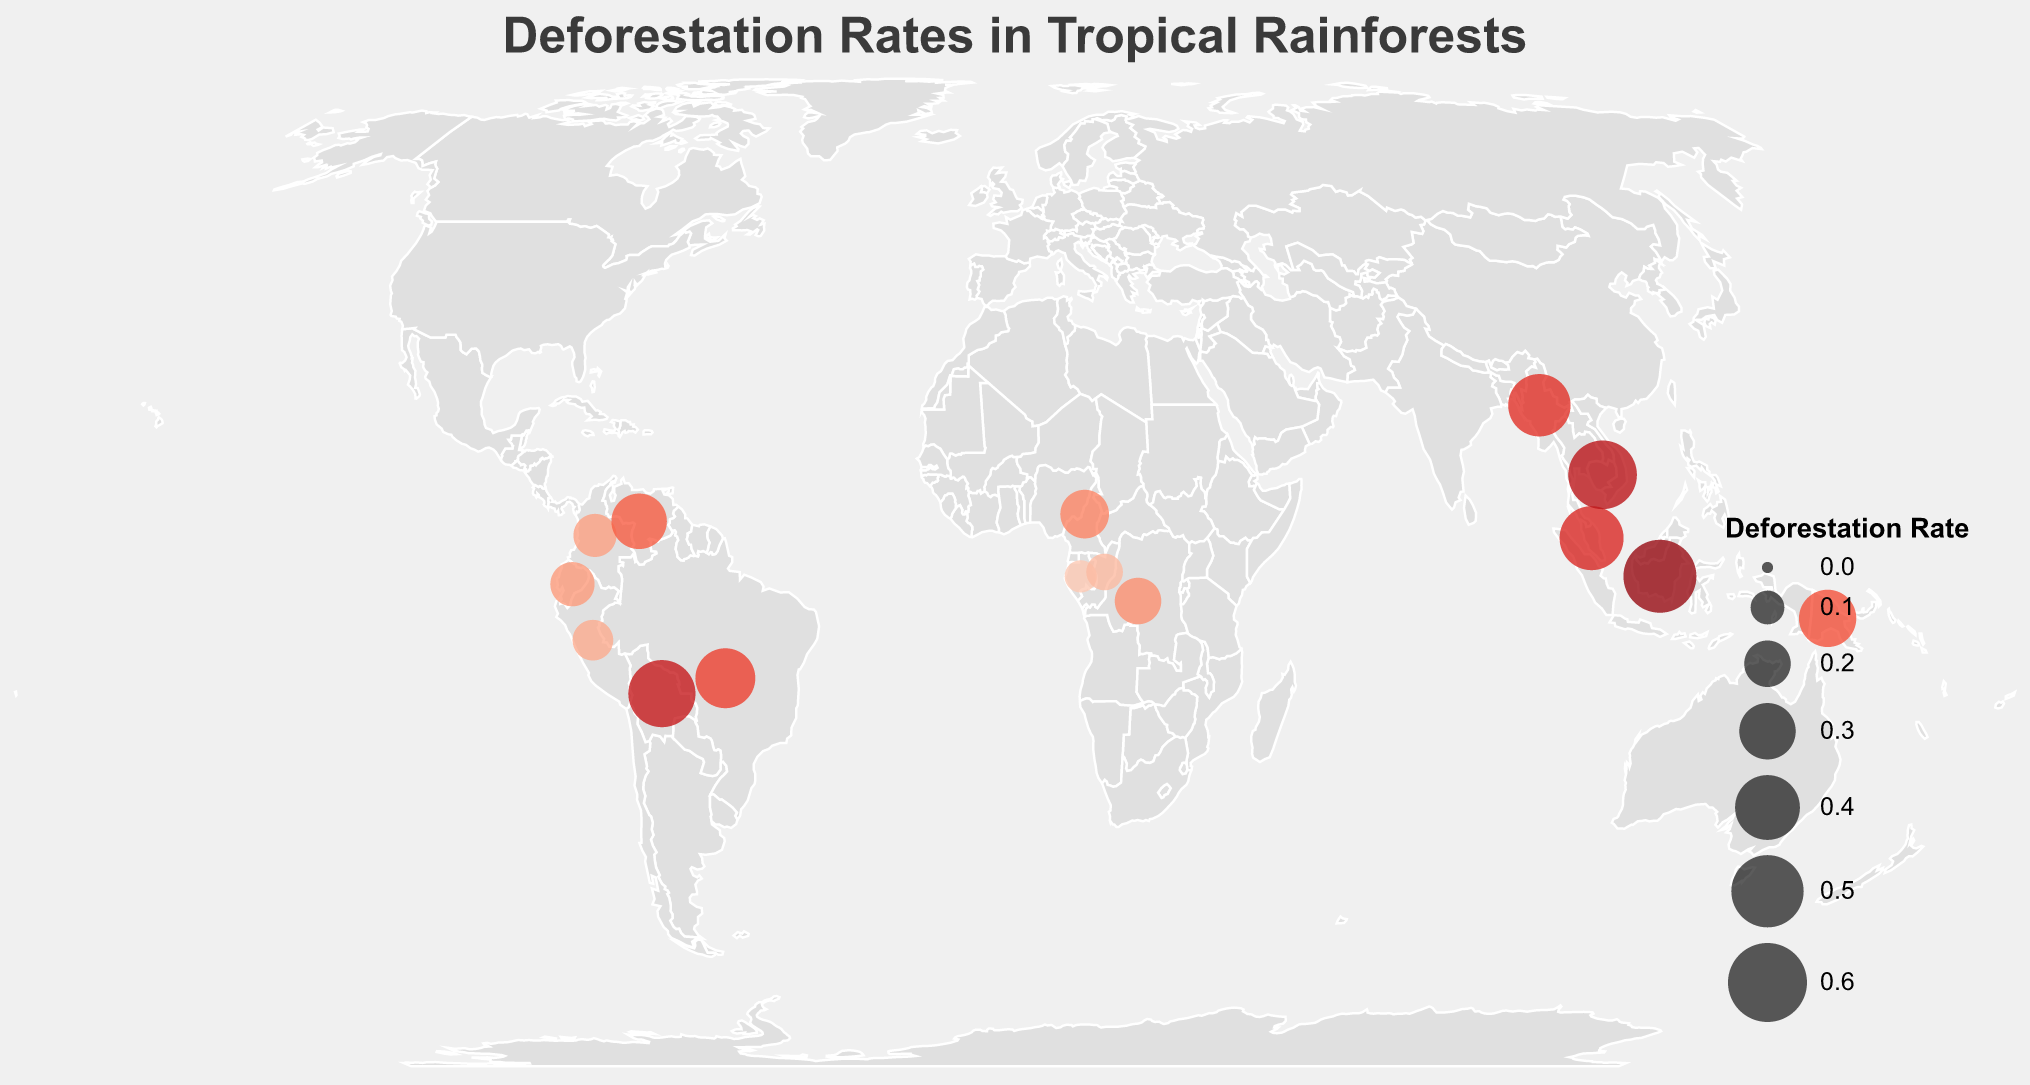What's the title of the figure? The title of the figure is displayed at the top and reads "Deforestation Rates in Tropical Rainforests".
Answer: Deforestation Rates in Tropical Rainforests How many countries are shown in the figure with deforestation rates? By counting the number of distinct data points or circles on the map, we can see there are 15 countries represented.
Answer: 15 Which country has the highest deforestation rate? By examining the figure and observing the sizes and colors of the circles representing deforestation rates, Indonesia has the largest circle, indicating the highest deforestation rate.
Answer: Indonesia What is the deforestation rate in Gabon? By hovering over or looking closely at the circle positioned over Gabon, the tooltip shows a deforestation rate of 0.09.
Answer: 0.09 Which two countries have similar deforestation rates of around 0.31? From the figure, the countries with deforestation rates close to 0.31 are Brazil (0.34) and Papua New Guinea (0.31), but the exact match for 0.31 can be confirmed for Papua New Guinea.
Answer: Brazil and Papua New Guinea Compare the deforestation rates of Brazil and Malaysia. Which country has a higher rate? By examining the figure and comparing the sizes and colors of the circles over Brazil and Malaysia, we can observe that Malaysia has a higher deforestation rate (0.39) than Brazil (0.34).
Answer: Malaysia What is the average deforestation rate of the countries located in South America in the figure? First, list the countries in South America with their rates: Brazil (0.34), Peru (0.15), Colombia (0.17), Bolivia (0.43), Venezuela (0.29), and Ecuador (0.18). Sum these rates: 0.34 + 0.15 + 0.17 + 0.43 + 0.29 + 0.18 = 1.56. Divide by the number of countries (6): 1.56 / 6 ≈ 0.26.
Answer: 0.26 Which continent shows the most countries with notable deforestation rates in this figure? By looking at the spread and density of circles on the map, South America shows the most countries with notable deforestation rates.
Answer: South America Identify the country with the lowest deforestation rate in the figure. By observing the sizes and color intensities of the circles, Gabon has the smallest and least intense circle, indicating the lowest deforestation rate of 0.09.
Answer: Gabon How does the deforestation rate of Cambodia compare to Myanmar? By comparing the circles over both countries, Cambodia has a slightly higher deforestation rate (0.45) compared to Myanmar (0.37).
Answer: Cambodia 